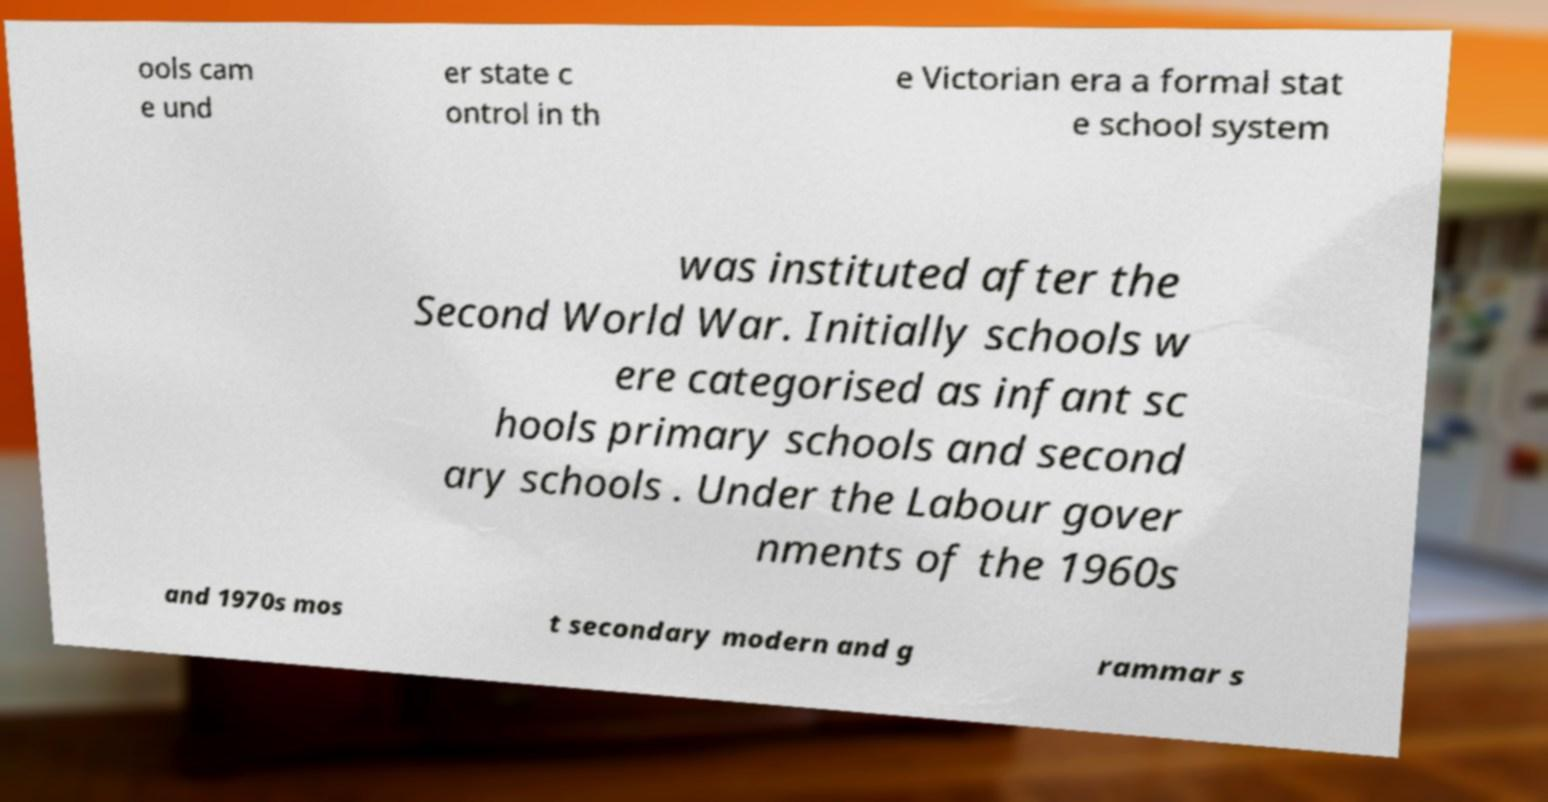Please read and relay the text visible in this image. What does it say? ools cam e und er state c ontrol in th e Victorian era a formal stat e school system was instituted after the Second World War. Initially schools w ere categorised as infant sc hools primary schools and second ary schools . Under the Labour gover nments of the 1960s and 1970s mos t secondary modern and g rammar s 